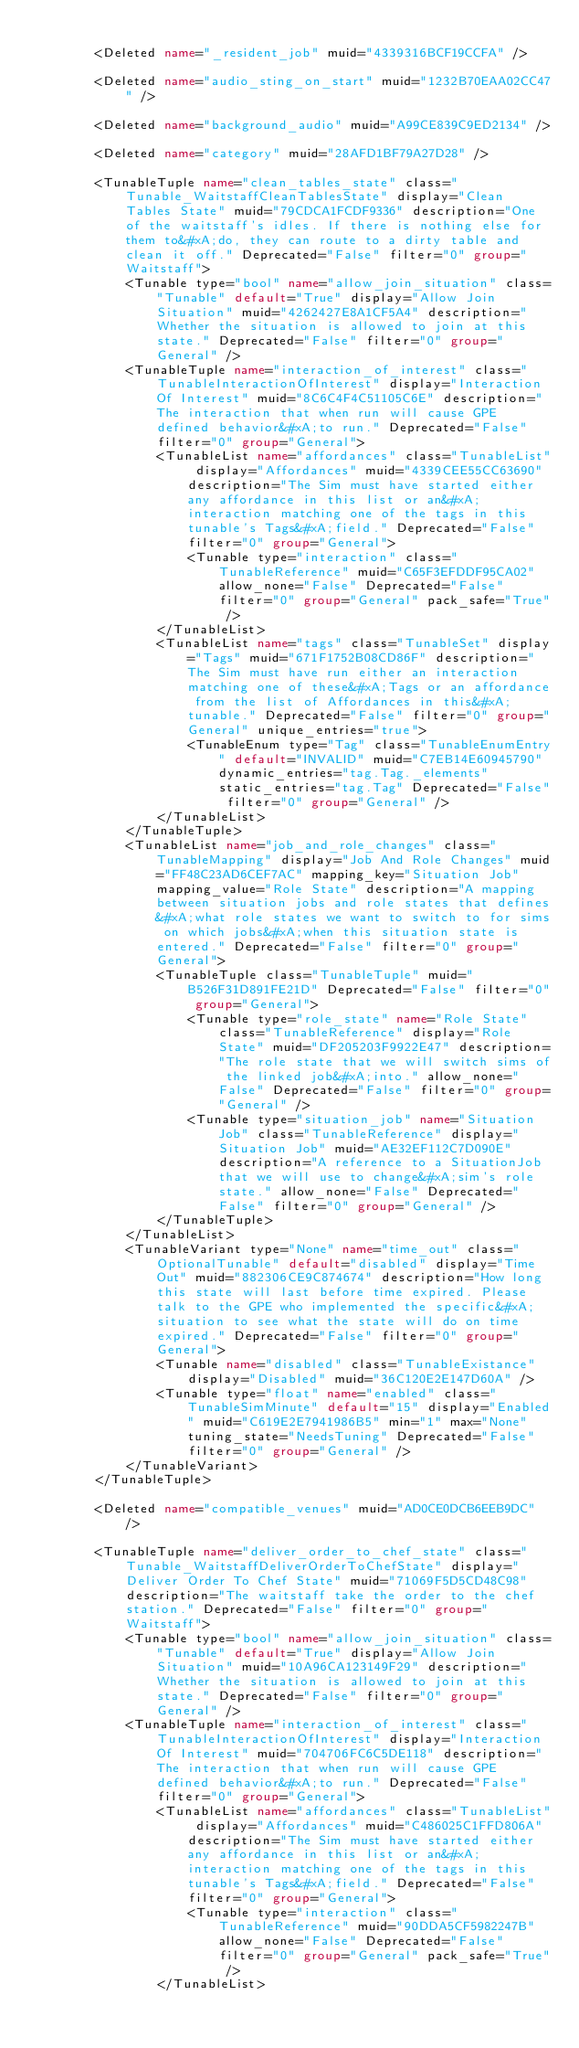<code> <loc_0><loc_0><loc_500><loc_500><_XML_>
        <Deleted name="_resident_job" muid="4339316BCF19CCFA" />

        <Deleted name="audio_sting_on_start" muid="1232B70EAA02CC47" />

        <Deleted name="background_audio" muid="A99CE839C9ED2134" />

        <Deleted name="category" muid="28AFD1BF79A27D28" />

        <TunableTuple name="clean_tables_state" class="Tunable_WaitstaffCleanTablesState" display="Clean Tables State" muid="79CDCA1FCDF9336" description="One of the waitstaff's idles. If there is nothing else for them to&#xA;do, they can route to a dirty table and clean it off." Deprecated="False" filter="0" group="Waitstaff">
            <Tunable type="bool" name="allow_join_situation" class="Tunable" default="True" display="Allow Join Situation" muid="4262427E8A1CF5A4" description="Whether the situation is allowed to join at this state." Deprecated="False" filter="0" group="General" />
            <TunableTuple name="interaction_of_interest" class="TunableInteractionOfInterest" display="Interaction Of Interest" muid="8C6C4F4C51105C6E" description="The interaction that when run will cause GPE defined behavior&#xA;to run." Deprecated="False" filter="0" group="General">
                <TunableList name="affordances" class="TunableList" display="Affordances" muid="4339CEE55CC63690" description="The Sim must have started either any affordance in this list or an&#xA;interaction matching one of the tags in this tunable's Tags&#xA;field." Deprecated="False" filter="0" group="General">
                    <Tunable type="interaction" class="TunableReference" muid="C65F3EFDDF95CA02" allow_none="False" Deprecated="False" filter="0" group="General" pack_safe="True" />
                </TunableList>
                <TunableList name="tags" class="TunableSet" display="Tags" muid="671F1752B08CD86F" description="The Sim must have run either an interaction matching one of these&#xA;Tags or an affordance from the list of Affordances in this&#xA;tunable." Deprecated="False" filter="0" group="General" unique_entries="true">
                    <TunableEnum type="Tag" class="TunableEnumEntry" default="INVALID" muid="C7EB14E60945790" dynamic_entries="tag.Tag._elements" static_entries="tag.Tag" Deprecated="False" filter="0" group="General" />
                </TunableList>
            </TunableTuple>
            <TunableList name="job_and_role_changes" class="TunableMapping" display="Job And Role Changes" muid="FF48C23AD6CEF7AC" mapping_key="Situation Job" mapping_value="Role State" description="A mapping between situation jobs and role states that defines&#xA;what role states we want to switch to for sims on which jobs&#xA;when this situation state is entered." Deprecated="False" filter="0" group="General">
                <TunableTuple class="TunableTuple" muid="B526F31D891FE21D" Deprecated="False" filter="0" group="General">
                    <Tunable type="role_state" name="Role State" class="TunableReference" display="Role State" muid="DF205203F9922E47" description="The role state that we will switch sims of the linked job&#xA;into." allow_none="False" Deprecated="False" filter="0" group="General" />
                    <Tunable type="situation_job" name="Situation Job" class="TunableReference" display="Situation Job" muid="AE32EF112C7D090E" description="A reference to a SituationJob that we will use to change&#xA;sim's role state." allow_none="False" Deprecated="False" filter="0" group="General" />
                </TunableTuple>
            </TunableList>
            <TunableVariant type="None" name="time_out" class="OptionalTunable" default="disabled" display="Time Out" muid="882306CE9C874674" description="How long this state will last before time expired. Please talk to the GPE who implemented the specific&#xA;situation to see what the state will do on time expired." Deprecated="False" filter="0" group="General">
                <Tunable name="disabled" class="TunableExistance" display="Disabled" muid="36C120E2E147D60A" />
                <Tunable type="float" name="enabled" class="TunableSimMinute" default="15" display="Enabled" muid="C619E2E7941986B5" min="1" max="None" tuning_state="NeedsTuning" Deprecated="False" filter="0" group="General" />
            </TunableVariant>
        </TunableTuple>

        <Deleted name="compatible_venues" muid="AD0CE0DCB6EEB9DC" />

        <TunableTuple name="deliver_order_to_chef_state" class="Tunable_WaitstaffDeliverOrderToChefState" display="Deliver Order To Chef State" muid="71069F5D5CD48C98" description="The waitstaff take the order to the chef station." Deprecated="False" filter="0" group="Waitstaff">
            <Tunable type="bool" name="allow_join_situation" class="Tunable" default="True" display="Allow Join Situation" muid="10A96CA123149F29" description="Whether the situation is allowed to join at this state." Deprecated="False" filter="0" group="General" />
            <TunableTuple name="interaction_of_interest" class="TunableInteractionOfInterest" display="Interaction Of Interest" muid="704706FC6C5DE118" description="The interaction that when run will cause GPE defined behavior&#xA;to run." Deprecated="False" filter="0" group="General">
                <TunableList name="affordances" class="TunableList" display="Affordances" muid="C486025C1FFD806A" description="The Sim must have started either any affordance in this list or an&#xA;interaction matching one of the tags in this tunable's Tags&#xA;field." Deprecated="False" filter="0" group="General">
                    <Tunable type="interaction" class="TunableReference" muid="90DDA5CF5982247B" allow_none="False" Deprecated="False" filter="0" group="General" pack_safe="True" />
                </TunableList></code> 